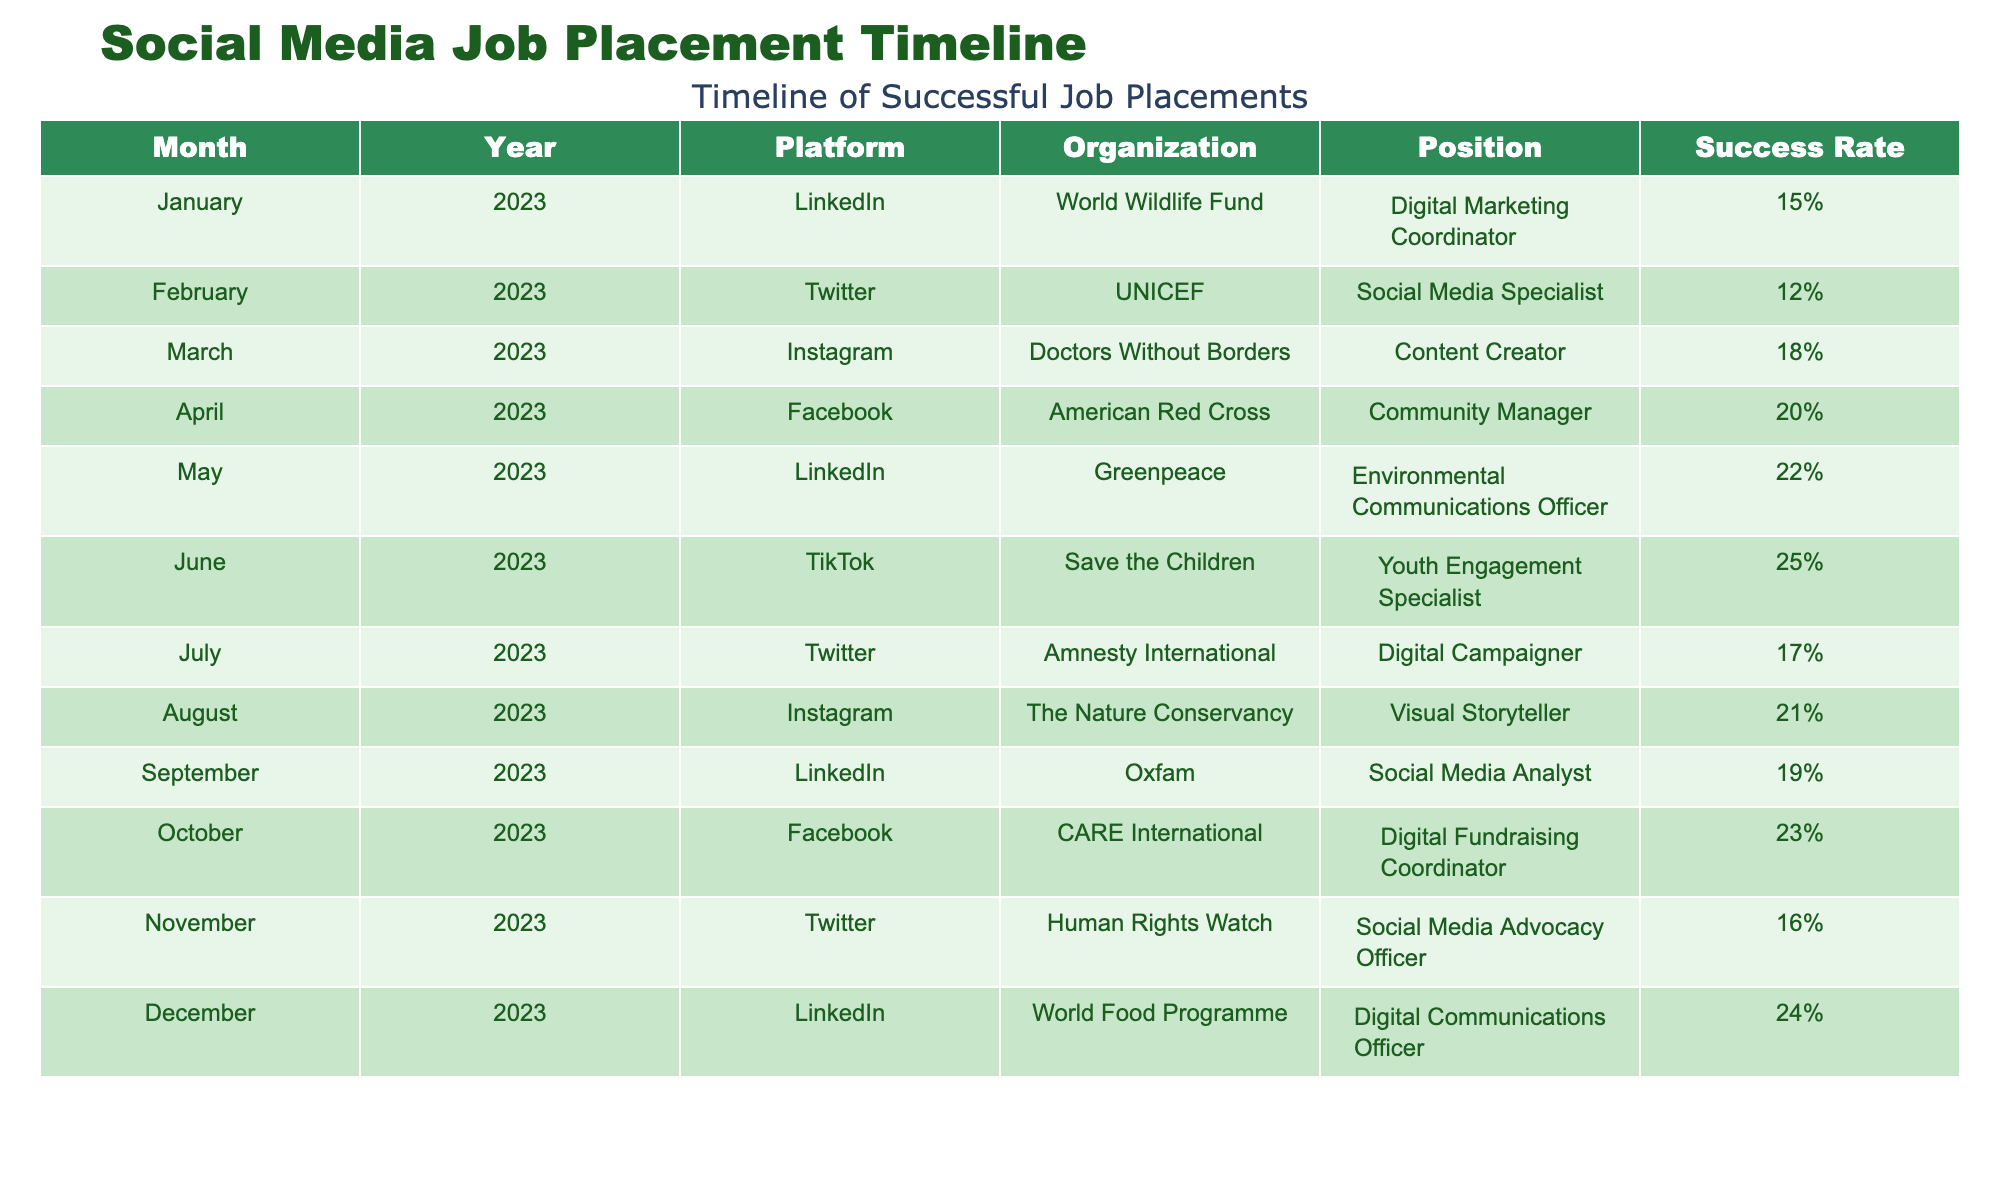What was the highest success rate achieved in 2023? The highest success rate in the table is 25%, which occurred in June 2023 when the position of Youth Engagement Specialist was offered by Save the Children.
Answer: 25% Which platform had the lowest success rate for job placements? The lowest success rate is 12%, achieved on Twitter in February 2023 for the position of Social Media Specialist at UNICEF.
Answer: 12% What is the average success rate for positions advertised on LinkedIn? The success rates for LinkedIn are 15%, 22%, 19%, and 24%. Adding those gives 80%, and dividing by 4 (the number of months) results in an average of 20%.
Answer: 20% Did any organization repeat success across multiple months? Yes, World Wildlife Fund successfully offered positions in January and December of 2023, indicating a repeat success.
Answer: Yes Which month had the highest success rate for job placements? The month with the highest success rate was June 2023, with a rate of 25% for the Youth Engagement Specialist position at Save the Children.
Answer: June 2023 What is the difference in success rates between the highest and lowest performing month? The highest success rate is 25% in June, and the lowest is 12% in February. The difference is 25 - 12 = 13%.
Answer: 13% Was there an increase in success rates over the months from January to December 2023? Analyzing the data, if we look at the monthly success rates, there is a general trend of increasing success, starting from 15% in January to 24% in December.
Answer: Yes Which organization had the most varied success rates across different months? Greenpeace had varied success rates, showing 22% in May but not having any entries in other months in this sample. Considering multiple months with varying rates, UNICEF had a success rate of 12% and others ranging as high as 25%.
Answer: UNICEF What was the total number of job placements offered through Twitter in 2023? Twitter had placements in February (12%), July (17%), and November (16%). Therefore, totaling these placements gives us 3 job placements offered throughout the year.
Answer: 3 